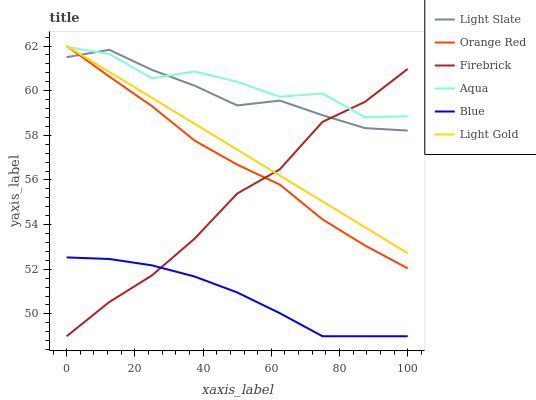Does Blue have the minimum area under the curve?
Answer yes or no. Yes. Does Aqua have the maximum area under the curve?
Answer yes or no. Yes. Does Light Slate have the minimum area under the curve?
Answer yes or no. No. Does Light Slate have the maximum area under the curve?
Answer yes or no. No. Is Light Gold the smoothest?
Answer yes or no. Yes. Is Aqua the roughest?
Answer yes or no. Yes. Is Light Slate the smoothest?
Answer yes or no. No. Is Light Slate the roughest?
Answer yes or no. No. Does Blue have the lowest value?
Answer yes or no. Yes. Does Light Slate have the lowest value?
Answer yes or no. No. Does Orange Red have the highest value?
Answer yes or no. Yes. Does Light Slate have the highest value?
Answer yes or no. No. Is Blue less than Light Gold?
Answer yes or no. Yes. Is Aqua greater than Blue?
Answer yes or no. Yes. Does Light Gold intersect Orange Red?
Answer yes or no. Yes. Is Light Gold less than Orange Red?
Answer yes or no. No. Is Light Gold greater than Orange Red?
Answer yes or no. No. Does Blue intersect Light Gold?
Answer yes or no. No. 